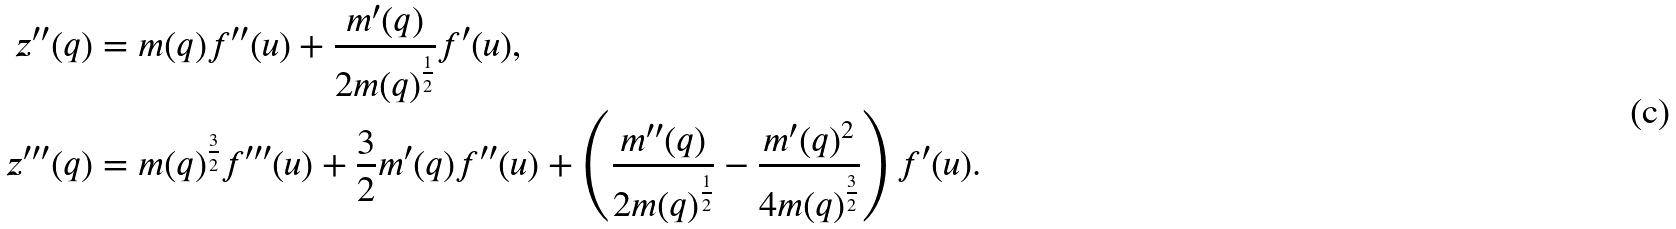Convert formula to latex. <formula><loc_0><loc_0><loc_500><loc_500>z ^ { \prime \prime } ( q ) & = m ( q ) f ^ { \prime \prime } ( u ) + \frac { m ^ { \prime } ( q ) } { 2 m ( q ) ^ { \frac { 1 } { 2 } } } f ^ { \prime } ( u ) , \\ z ^ { \prime \prime \prime } ( q ) & = m ( q ) ^ { \frac { 3 } { 2 } } f ^ { \prime \prime \prime } ( u ) + \frac { 3 } { 2 } m ^ { \prime } ( q ) f ^ { \prime \prime } ( u ) + \left ( \frac { m ^ { \prime \prime } ( q ) } { 2 m ( q ) ^ { \frac { 1 } { 2 } } } - \frac { m ^ { \prime } ( q ) ^ { 2 } } { 4 m ( q ) ^ { \frac { 3 } { 2 } } } \right ) f ^ { \prime } ( u ) .</formula> 